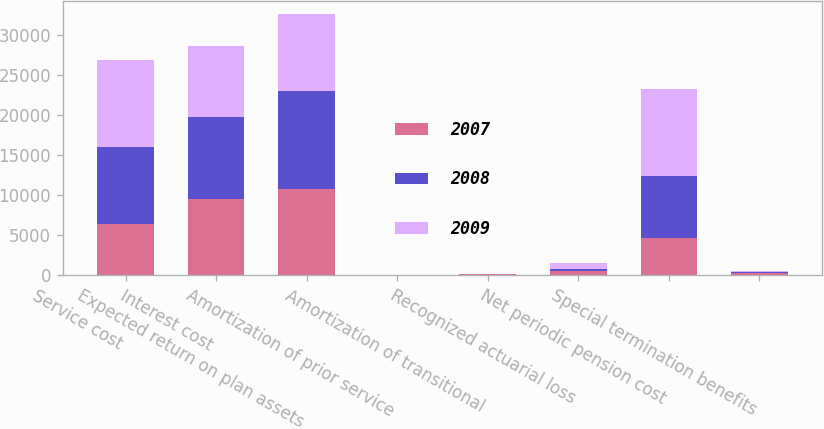Convert chart. <chart><loc_0><loc_0><loc_500><loc_500><stacked_bar_chart><ecel><fcel>Service cost<fcel>Interest cost<fcel>Expected return on plan assets<fcel>Amortization of prior service<fcel>Amortization of transitional<fcel>Recognized actuarial loss<fcel>Net periodic pension cost<fcel>Special termination benefits<nl><fcel>2007<fcel>6368<fcel>9525<fcel>10703<fcel>5<fcel>40<fcel>519<fcel>4636<fcel>281<nl><fcel>2008<fcel>9580<fcel>10234<fcel>12312<fcel>8<fcel>44<fcel>189<fcel>7655<fcel>15<nl><fcel>2009<fcel>10890<fcel>8862<fcel>9584<fcel>8<fcel>39<fcel>804<fcel>10941<fcel>207<nl></chart> 